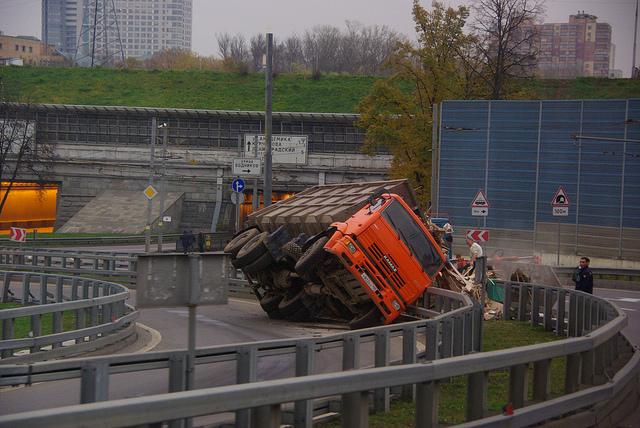Is the truck moving?
Keep it brief. No. Which side did this truck tip over on?
Write a very short answer. Left. What color is the truck?
Quick response, please. Orange. 